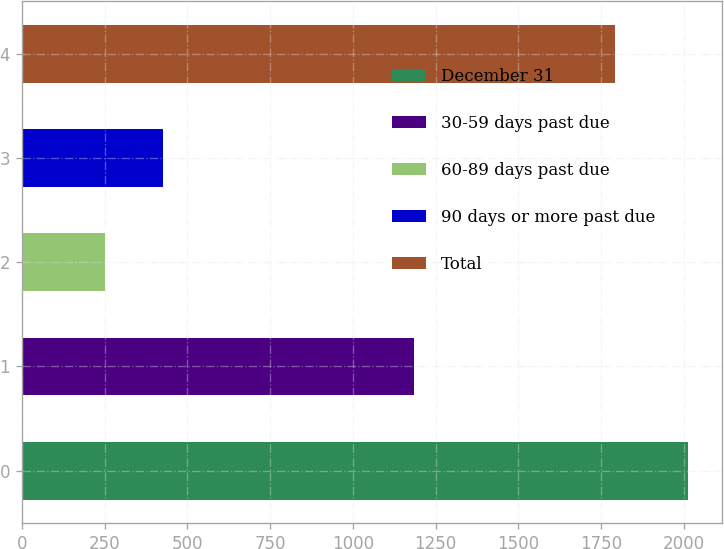Convert chart. <chart><loc_0><loc_0><loc_500><loc_500><bar_chart><fcel>December 31<fcel>30-59 days past due<fcel>60-89 days past due<fcel>90 days or more past due<fcel>Total<nl><fcel>2013<fcel>1185<fcel>251<fcel>427.2<fcel>1791<nl></chart> 